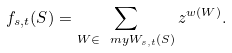<formula> <loc_0><loc_0><loc_500><loc_500>f _ { s , t } ( S ) = \sum _ { W \in \ m y W _ { s , t } ( S ) } z ^ { w ( W ) } .</formula> 